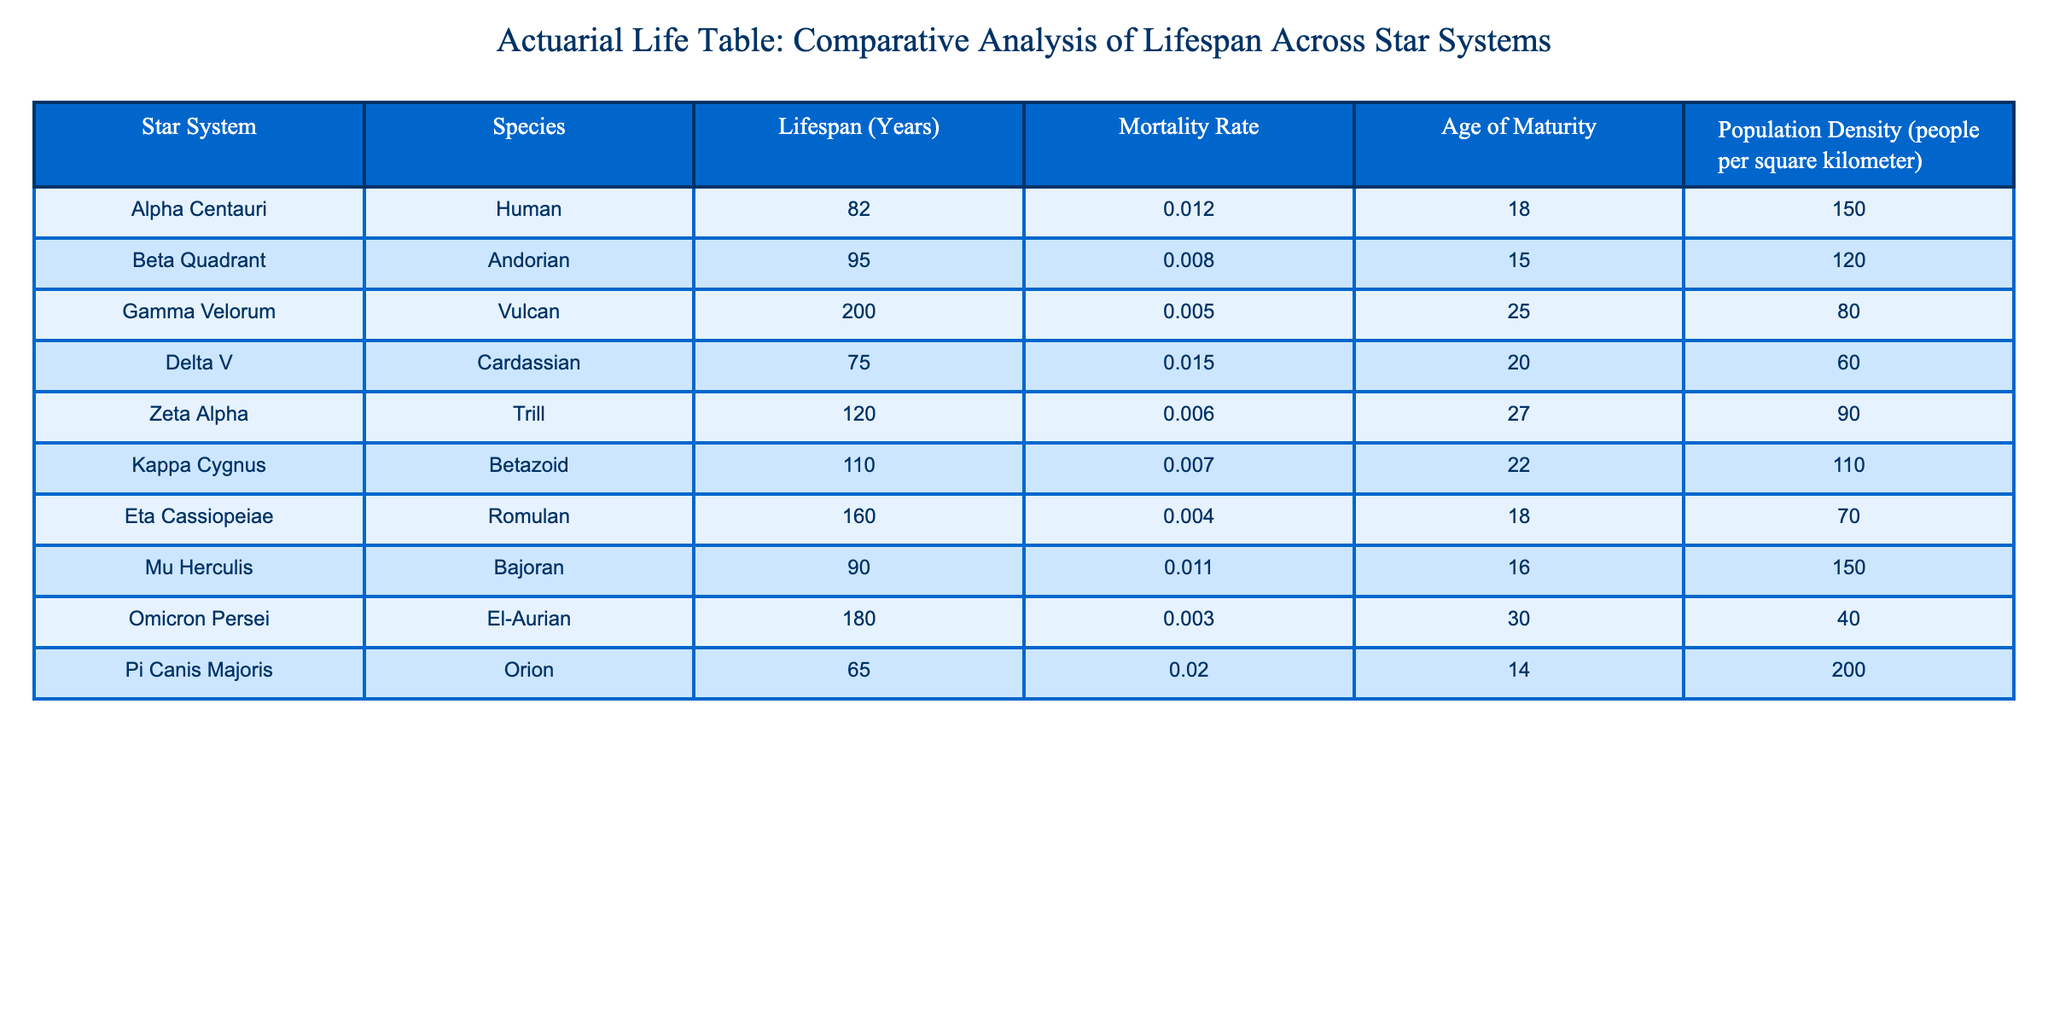What is the lifespan of the Vulcan species in the Gamma Velorum star system? The table clearly lists the lifespan for each species along with their respective star systems. For Vulcans in Gamma Velorum, the table states the lifespan is 200 years.
Answer: 200 years What is the mortality rate for Trill in the Zeta Alpha star system? By referring to the table, we find the entry for Trill in the Zeta Alpha star system specifically mentions a mortality rate of 0.006.
Answer: 0.006 Which species has the lowest population density based on the table? Analyzing the population density column, we compare the values across all species. The lowest population density listed is for El-Aurian at 40 people per square kilometer.
Answer: El-Aurian What is the average lifespan of the species in the Delta V and Beta Quadrant star systems? The lifespans for the species in those star systems are: Delta V has 75 years (Cardassian) and Beta Quadrant has 95 years (Andorian). To find the average, we calculate (75 + 95) / 2 = 85 years.
Answer: 85 years Is the mortality rate for Bajorans higher than that for Romulans? By examining the mortality rates in the table, Bajorans have a mortality rate of 0.011 while Romulans have 0.004. Since 0.011 is greater than 0.004, the statement is true.
Answer: Yes What is the total lifespan of species in the Kappa Cygnus and Omicron Persei star systems combined? From the table, Kappa Cygnus (Betazoid) has a lifespan of 110 years and Omicron Persei (El-Aurian) has 180 years. Adding them together gives 110 + 180 = 290 years.
Answer: 290 years How does the age of maturity for Humans compare to that for Bajorans? The table shows that Humans mature at 18 years while Bajorans mature at 16 years. Since 18 is greater than 16, it indicates that Humans have a later age of maturity than Bajorans.
Answer: Humans mature later Which species has a lifespan of less than 80 years? A review of the lifespan column shows that the only species with a lifespan under 80 years is the Orion from Pi Canis Majoris at 65 years.
Answer: Orion What is the median lifespan of the species listed in this table? To find the median, we first arrange the lifespans in ascending order: 65, 75, 82, 90, 95, 110, 120, 160, 180, 200. There are 10 data points, so the median is the average of the 5th and 6th values, which are 95 and 110. Calculating (95 + 110) / 2 = 102.5 gives us the median lifespan.
Answer: 102.5 years 